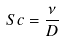<formula> <loc_0><loc_0><loc_500><loc_500>S c = \frac { \nu } { D }</formula> 